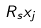Convert formula to latex. <formula><loc_0><loc_0><loc_500><loc_500>R _ { s } x _ { j }</formula> 